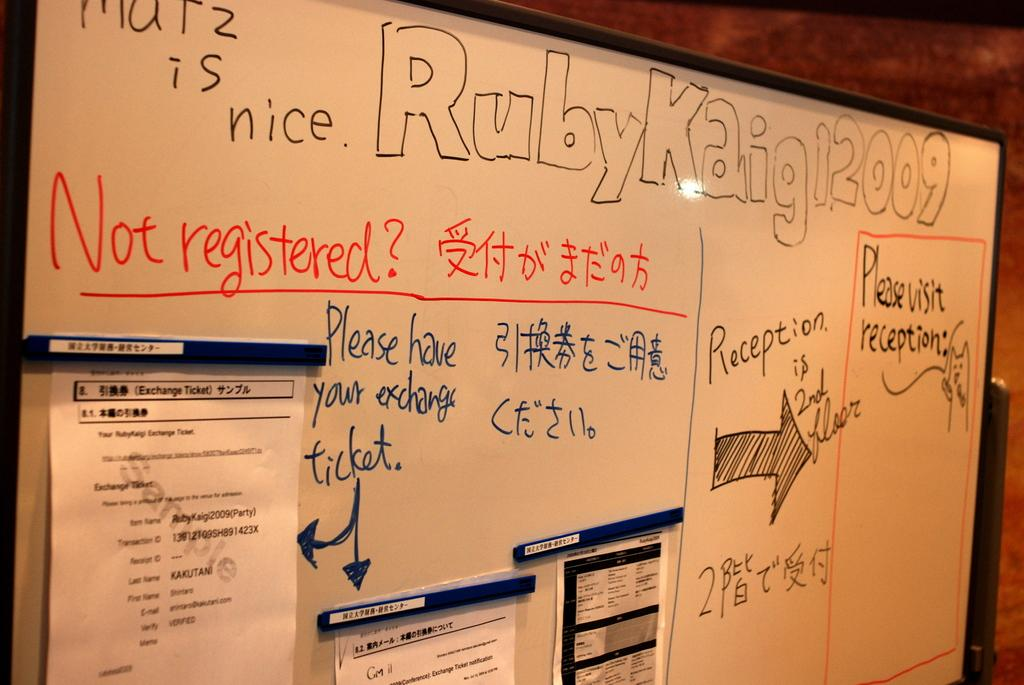<image>
Create a compact narrative representing the image presented. A white board with the words Ruby Kaigi12009 written across the top. 